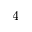<formula> <loc_0><loc_0><loc_500><loc_500>_ { 4 }</formula> 